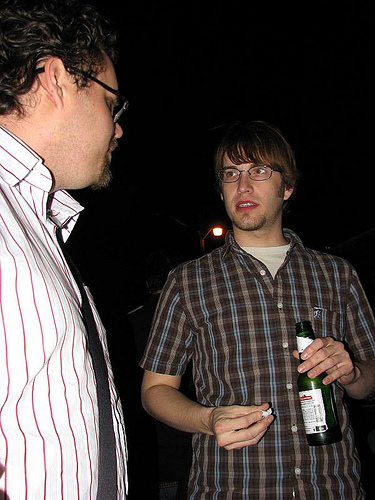<image>
Is there a man to the left of the man? Yes. From this viewpoint, the man is positioned to the left side relative to the man. Where is the man in relation to the dark? Is it behind the dark? No. The man is not behind the dark. From this viewpoint, the man appears to be positioned elsewhere in the scene. 